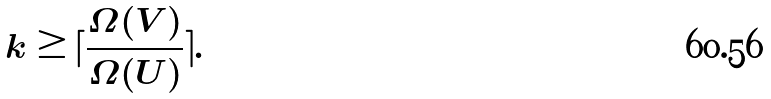Convert formula to latex. <formula><loc_0><loc_0><loc_500><loc_500>k \geq \lceil \frac { \Omega ( V ) } { \Omega ( U ) } \rceil .</formula> 